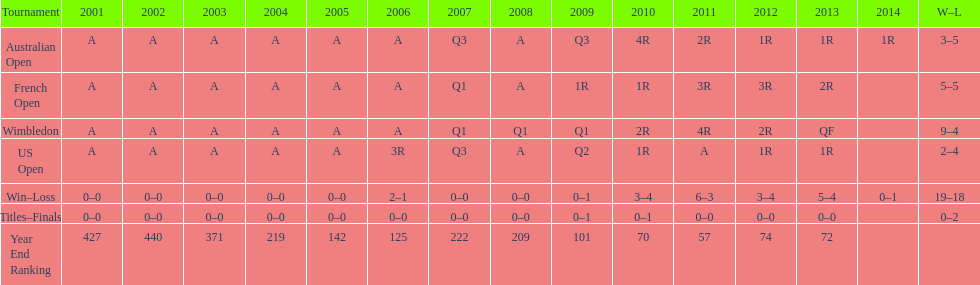What was the total number of matches played from 2001 to 2014? 37. 